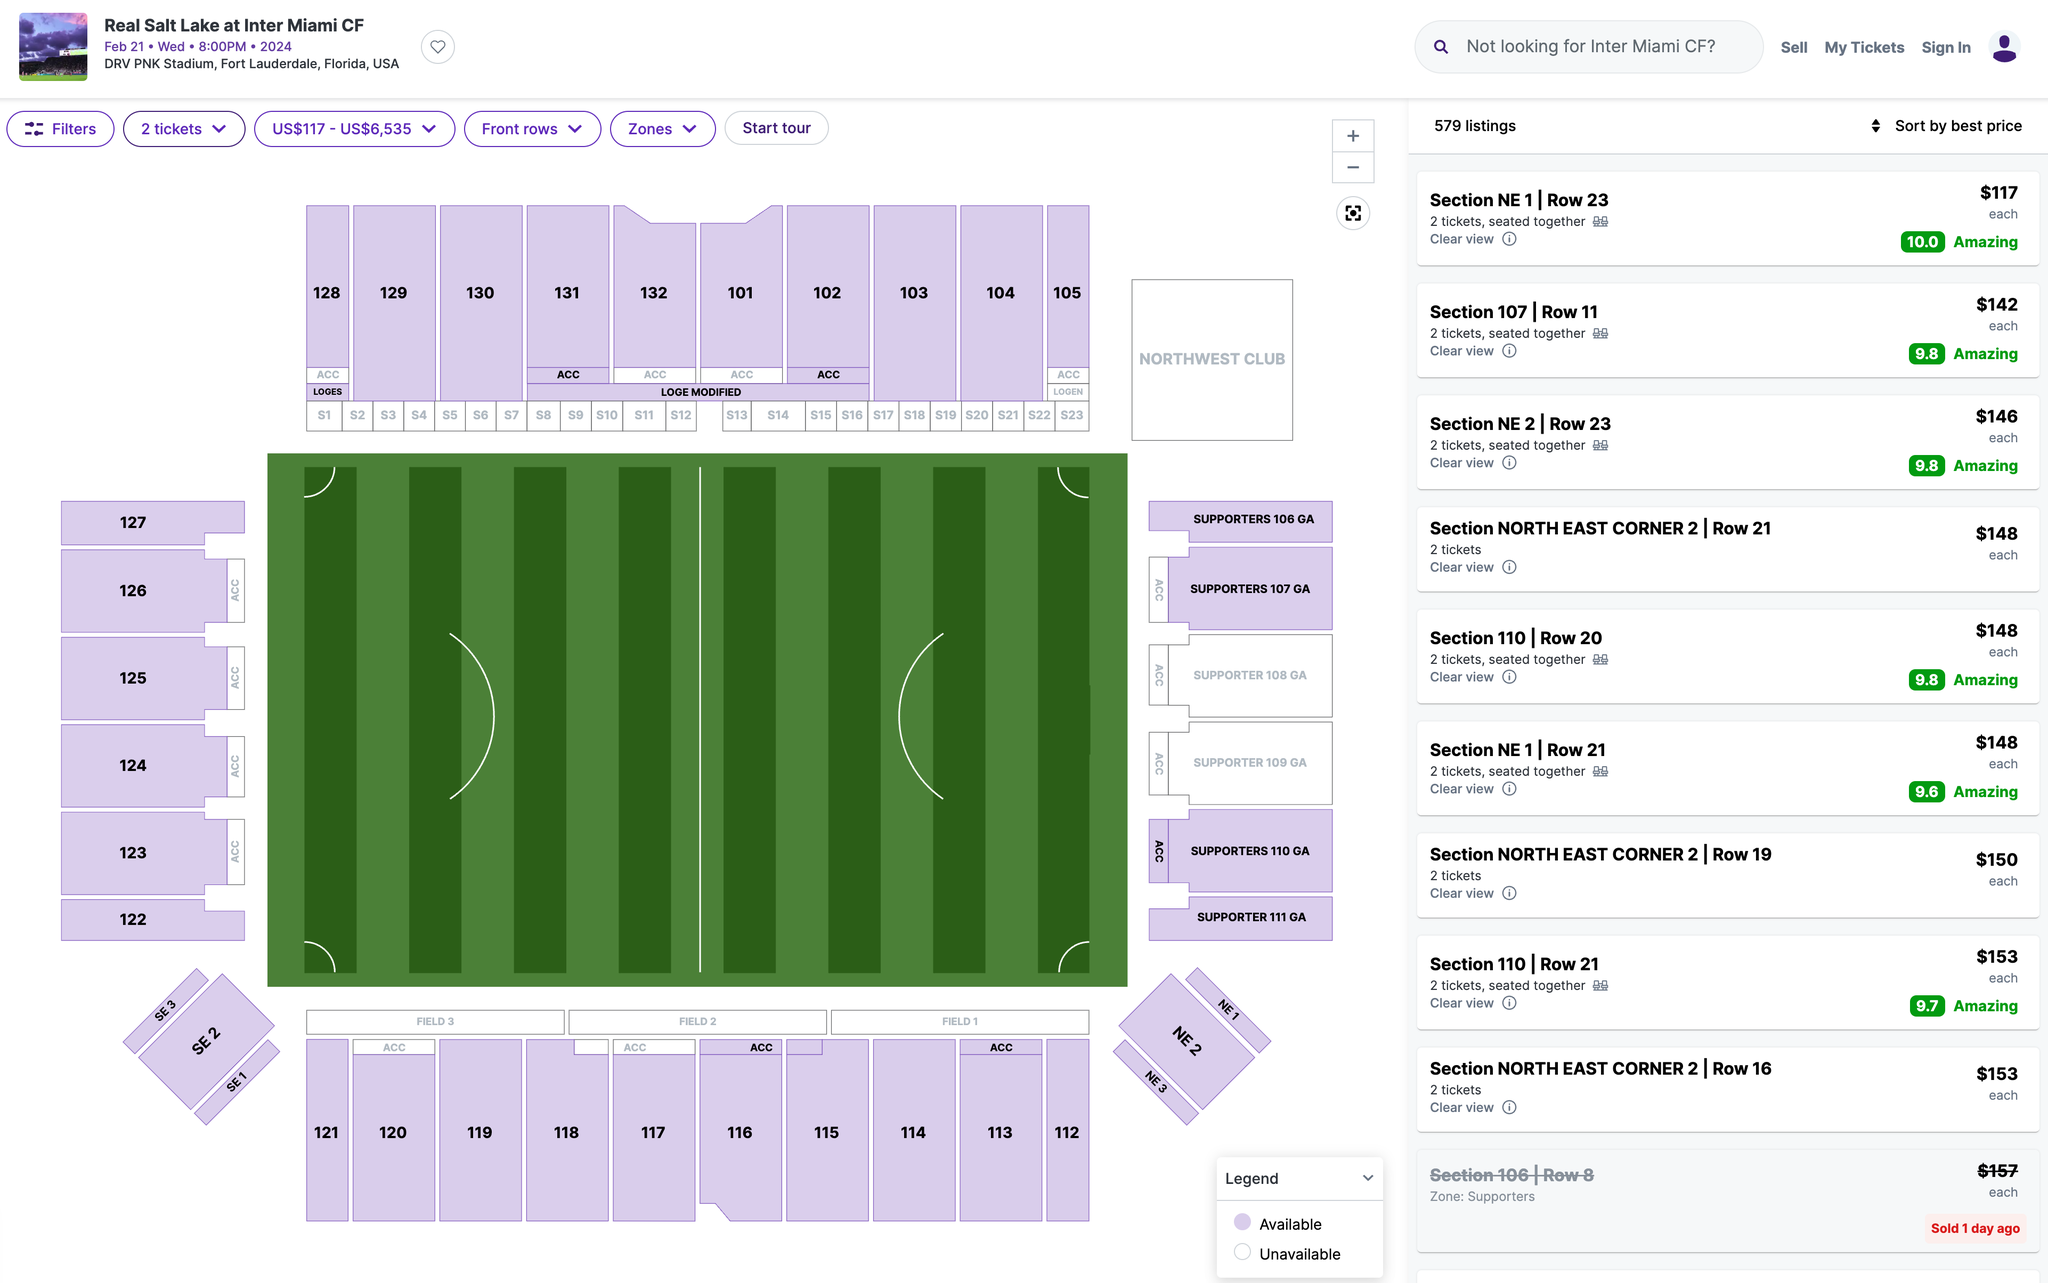Which section's ticket would you recommend I purchase? When choosing a section for purchasing tickets at a stadium event, several factors can influence your decision, such as your budget, the type of experience you want, and how close you would like to be to the action.

Based on the image provided, if budget is not a concern and you're looking for a premium experience, the sections labeled with "ACC" (which likely stands for "Accessible" or could be a premium section designation) along the sides of the field (e.g., Sections 101-105 and 113-117) generally provide a good view of the entire field and are close to the action without being too low to miss some perspective.

If you're looking to be part of a more energetic fan experience, the "Supporters" sections (e.g., Supporters 108 GA through Supporters 111 GA) are typically where the most devoted fans gather, sing, and cheer, creating a vibrant atmosphere.

The "Northwest Club" appears to be a premium option that might offer additional amenities such as indoor areas, food and drink options, and other comforts.

The sections in the corners (e.g., North East Corner 2) can offer a unique diagonal perspective on the game, and they're often a bit cheaper than the central sideline seats while still providing a clear view.

The "NE 1" section, particularly in rows 21-23, is rated as having an "amazing" view, suggesting that these seats offer a particularly good vantage point for watching the game.

Ultimately, the best section for you will depend on your personal preferences and what you value most in your game-day experience. If you'd like to be close to the action and don't mind paying a bit more, the middle sections on the sides might be the best. If you're looking for value and a good view, the corner sections might be a great choice. If atmosphere is your top priority, go for the Supporters sections. 